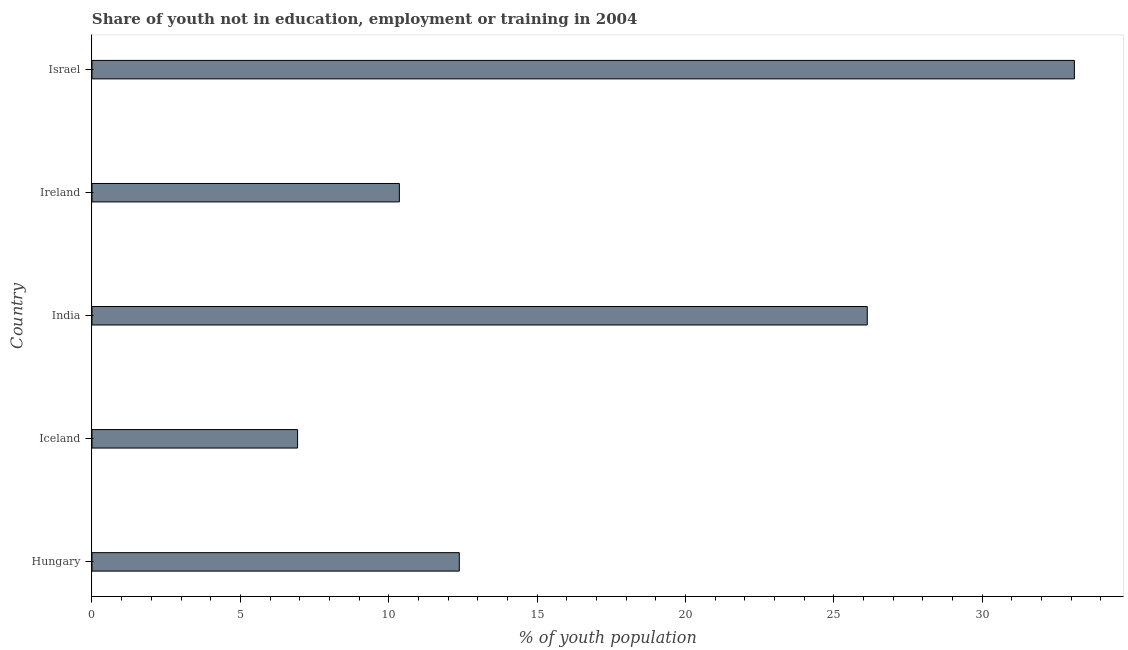Does the graph contain any zero values?
Your response must be concise. No. Does the graph contain grids?
Your answer should be compact. No. What is the title of the graph?
Provide a succinct answer. Share of youth not in education, employment or training in 2004. What is the label or title of the X-axis?
Ensure brevity in your answer.  % of youth population. What is the unemployed youth population in Hungary?
Offer a terse response. 12.38. Across all countries, what is the maximum unemployed youth population?
Ensure brevity in your answer.  33.11. Across all countries, what is the minimum unemployed youth population?
Give a very brief answer. 6.93. In which country was the unemployed youth population maximum?
Keep it short and to the point. Israel. What is the sum of the unemployed youth population?
Offer a very short reply. 88.91. What is the difference between the unemployed youth population in Ireland and Israel?
Your answer should be compact. -22.75. What is the average unemployed youth population per country?
Make the answer very short. 17.78. What is the median unemployed youth population?
Your answer should be very brief. 12.38. What is the ratio of the unemployed youth population in Hungary to that in India?
Make the answer very short. 0.47. Is the unemployed youth population in India less than that in Ireland?
Give a very brief answer. No. Is the difference between the unemployed youth population in Hungary and Iceland greater than the difference between any two countries?
Offer a terse response. No. What is the difference between the highest and the second highest unemployed youth population?
Your answer should be very brief. 6.98. Is the sum of the unemployed youth population in Ireland and Israel greater than the maximum unemployed youth population across all countries?
Offer a very short reply. Yes. What is the difference between the highest and the lowest unemployed youth population?
Provide a short and direct response. 26.18. In how many countries, is the unemployed youth population greater than the average unemployed youth population taken over all countries?
Provide a succinct answer. 2. Are all the bars in the graph horizontal?
Make the answer very short. Yes. What is the % of youth population of Hungary?
Provide a short and direct response. 12.38. What is the % of youth population of Iceland?
Offer a very short reply. 6.93. What is the % of youth population of India?
Ensure brevity in your answer.  26.13. What is the % of youth population of Ireland?
Your answer should be compact. 10.36. What is the % of youth population in Israel?
Provide a short and direct response. 33.11. What is the difference between the % of youth population in Hungary and Iceland?
Make the answer very short. 5.45. What is the difference between the % of youth population in Hungary and India?
Ensure brevity in your answer.  -13.75. What is the difference between the % of youth population in Hungary and Ireland?
Offer a very short reply. 2.02. What is the difference between the % of youth population in Hungary and Israel?
Your answer should be very brief. -20.73. What is the difference between the % of youth population in Iceland and India?
Offer a very short reply. -19.2. What is the difference between the % of youth population in Iceland and Ireland?
Give a very brief answer. -3.43. What is the difference between the % of youth population in Iceland and Israel?
Keep it short and to the point. -26.18. What is the difference between the % of youth population in India and Ireland?
Your answer should be compact. 15.77. What is the difference between the % of youth population in India and Israel?
Make the answer very short. -6.98. What is the difference between the % of youth population in Ireland and Israel?
Make the answer very short. -22.75. What is the ratio of the % of youth population in Hungary to that in Iceland?
Offer a terse response. 1.79. What is the ratio of the % of youth population in Hungary to that in India?
Offer a terse response. 0.47. What is the ratio of the % of youth population in Hungary to that in Ireland?
Your answer should be compact. 1.2. What is the ratio of the % of youth population in Hungary to that in Israel?
Provide a succinct answer. 0.37. What is the ratio of the % of youth population in Iceland to that in India?
Your response must be concise. 0.27. What is the ratio of the % of youth population in Iceland to that in Ireland?
Keep it short and to the point. 0.67. What is the ratio of the % of youth population in Iceland to that in Israel?
Ensure brevity in your answer.  0.21. What is the ratio of the % of youth population in India to that in Ireland?
Keep it short and to the point. 2.52. What is the ratio of the % of youth population in India to that in Israel?
Provide a succinct answer. 0.79. What is the ratio of the % of youth population in Ireland to that in Israel?
Provide a succinct answer. 0.31. 